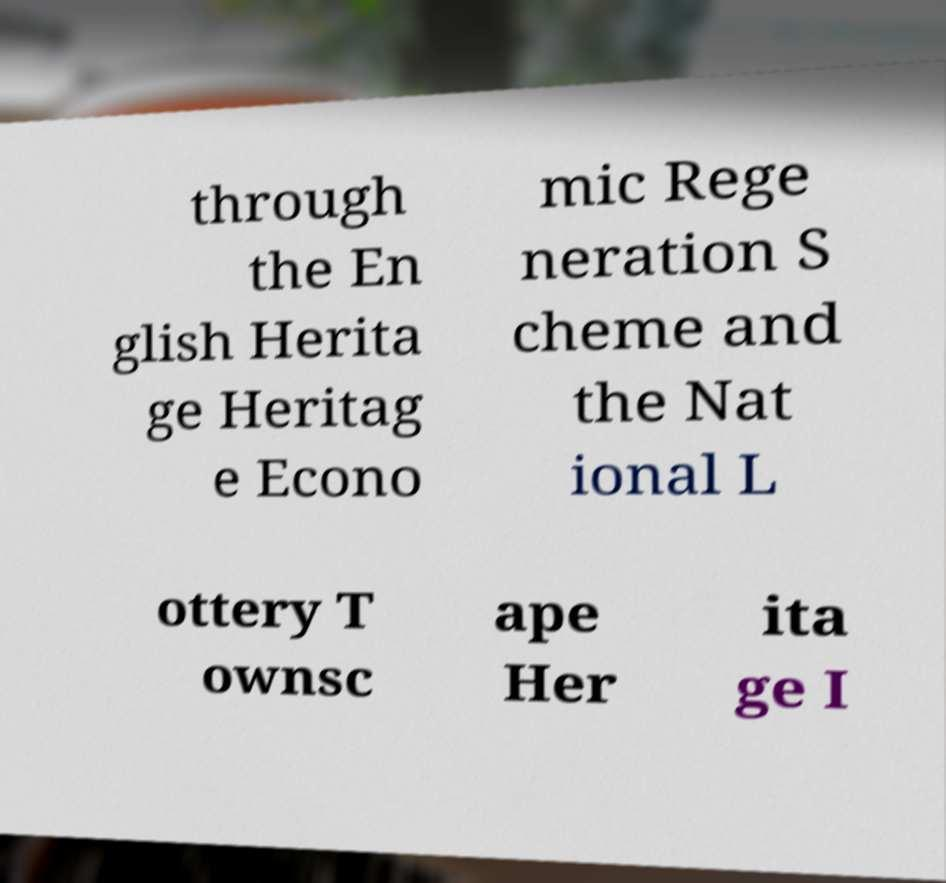Can you accurately transcribe the text from the provided image for me? through the En glish Herita ge Heritag e Econo mic Rege neration S cheme and the Nat ional L ottery T ownsc ape Her ita ge I 